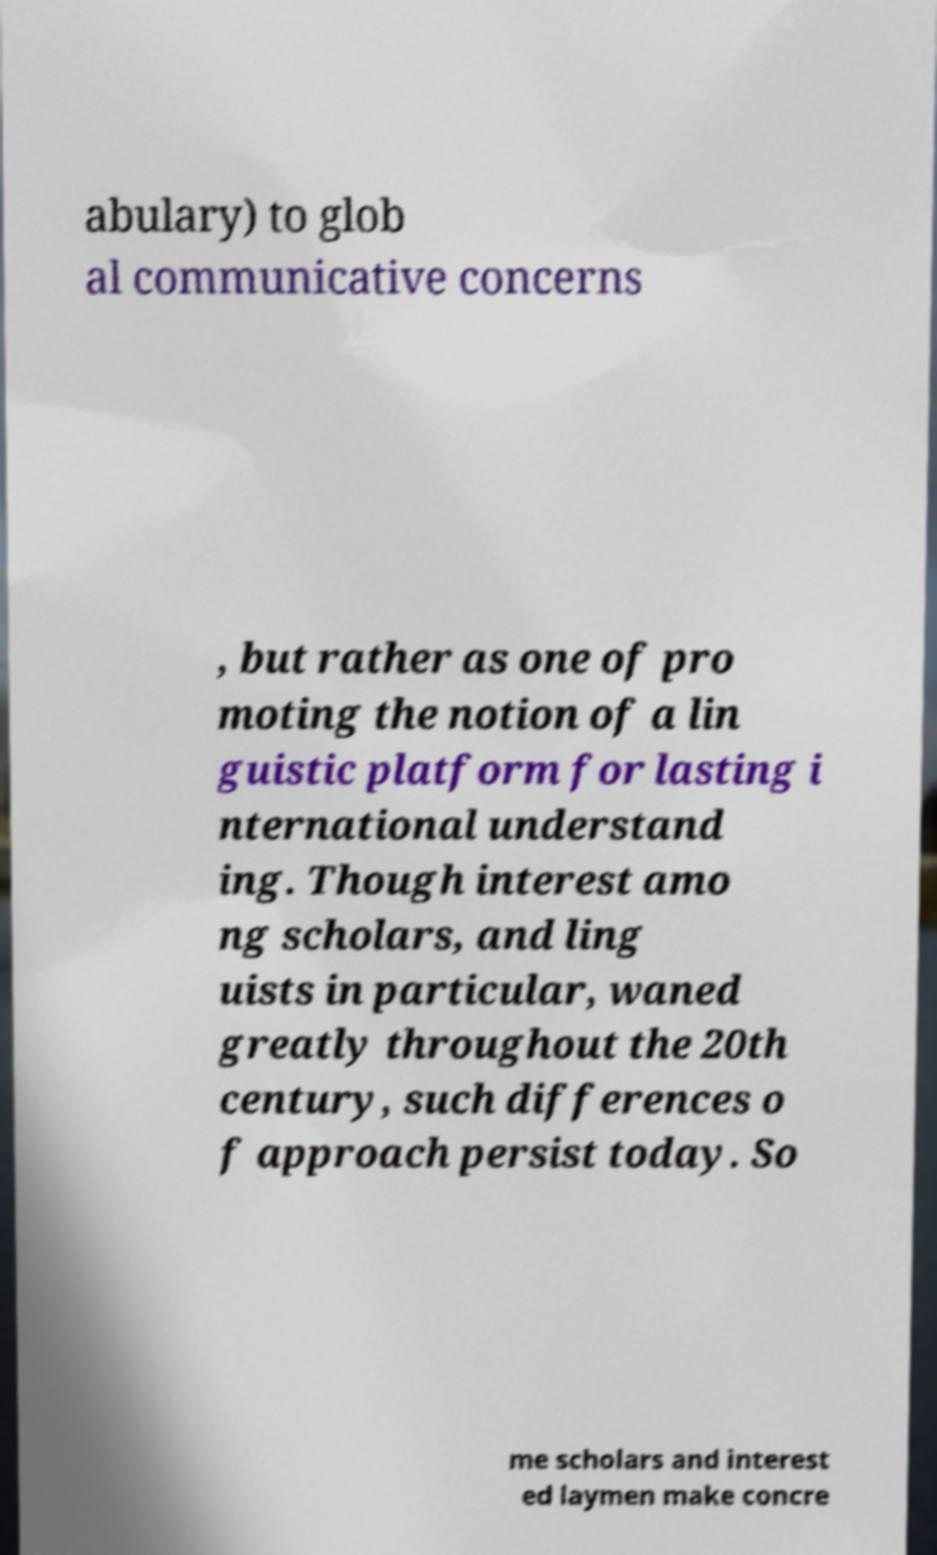I need the written content from this picture converted into text. Can you do that? abulary) to glob al communicative concerns , but rather as one of pro moting the notion of a lin guistic platform for lasting i nternational understand ing. Though interest amo ng scholars, and ling uists in particular, waned greatly throughout the 20th century, such differences o f approach persist today. So me scholars and interest ed laymen make concre 